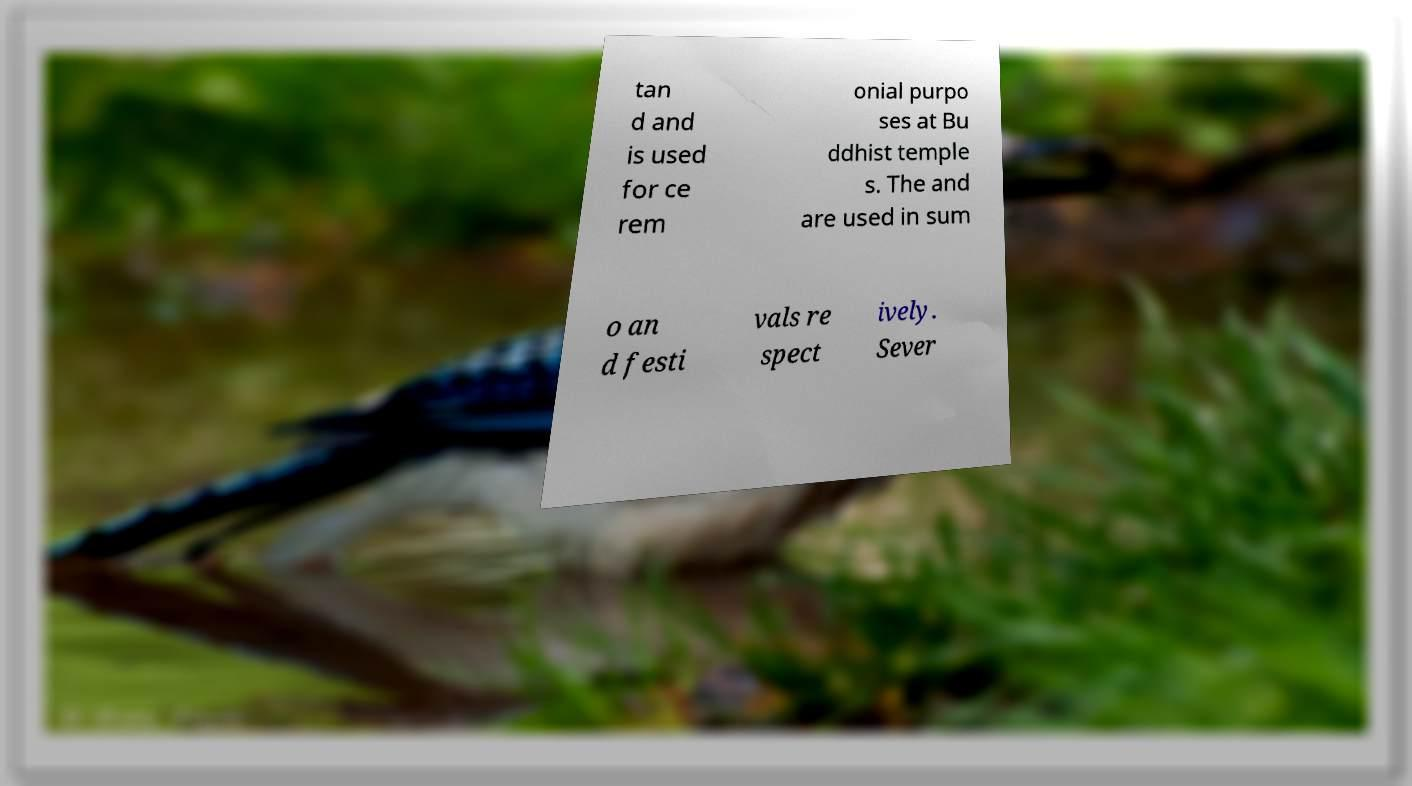Could you extract and type out the text from this image? tan d and is used for ce rem onial purpo ses at Bu ddhist temple s. The and are used in sum o an d festi vals re spect ively. Sever 